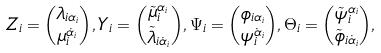<formula> <loc_0><loc_0><loc_500><loc_500>Z _ { i } = \binom { \lambda _ { i \alpha _ { i } } } { \mu _ { i } ^ { \dot { \alpha } _ { i } } } , Y _ { i } = \binom { \tilde { \mu } _ { i } ^ { \alpha _ { i } } } { \tilde { \lambda } _ { i \dot { \alpha } _ { i } } } , \Psi _ { i } = \binom { \phi _ { i \alpha _ { i } } } { \psi _ { i } ^ { \dot { \alpha } _ { i } } } , \Theta _ { i } = \binom { \tilde { \psi } _ { i } ^ { \alpha _ { i } } } { \tilde { \phi } _ { i \dot { \alpha } _ { i } } } ,</formula> 